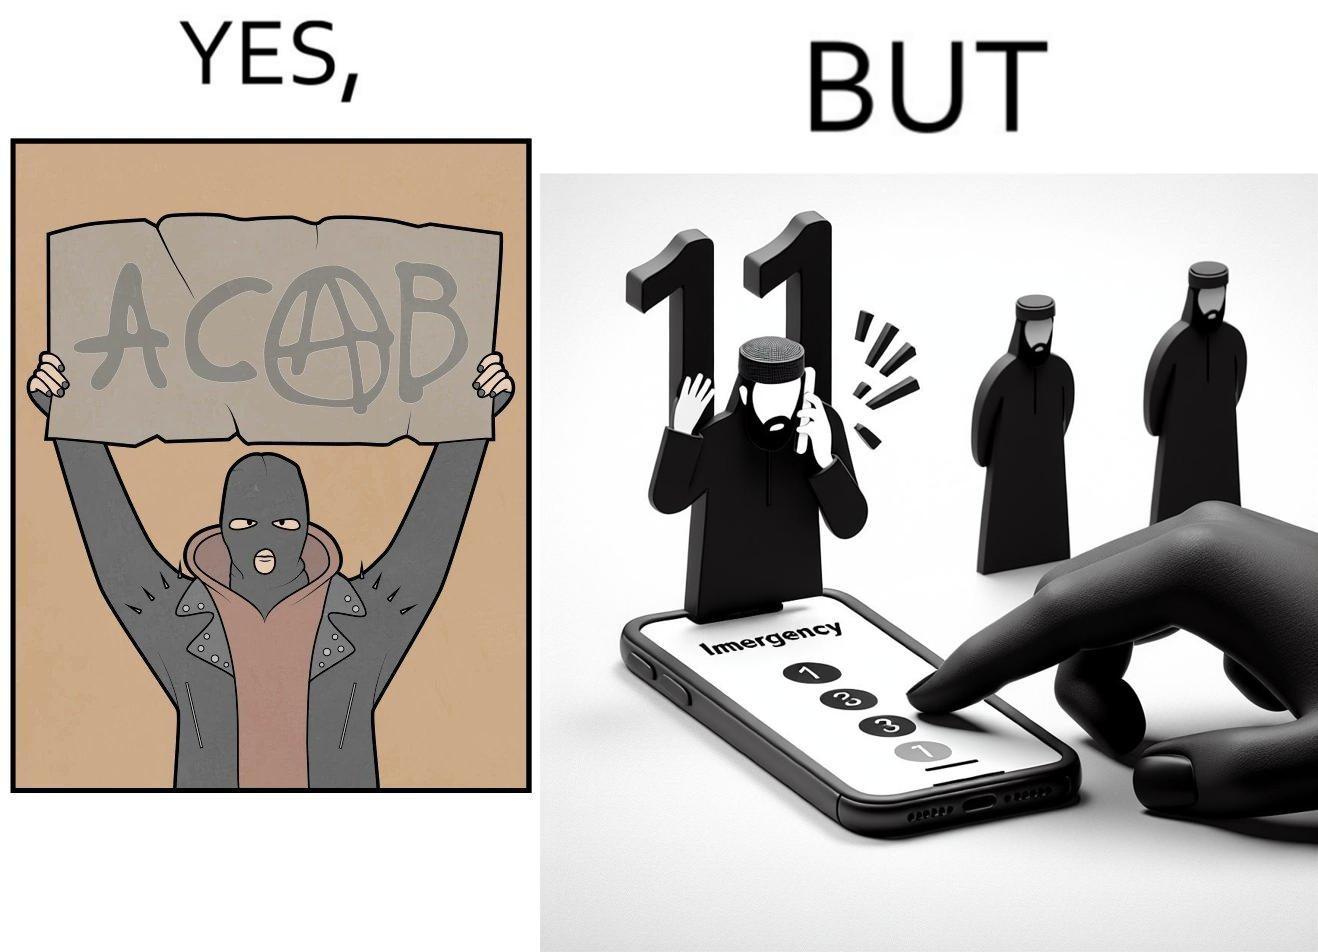What makes this image funny or satirical? This is funny because on the one hand this person is rebelling against cops (slogan being All Cops Are Bad - ACAB), but on the other hand they are also calling the cops for help. 